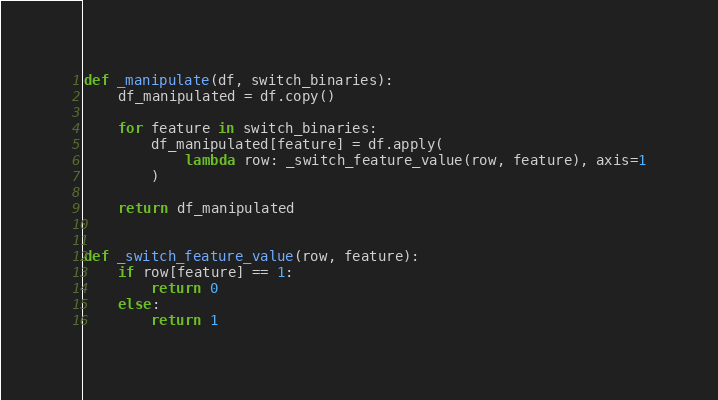Convert code to text. <code><loc_0><loc_0><loc_500><loc_500><_Python_>def _manipulate(df, switch_binaries):
    df_manipulated = df.copy()

    for feature in switch_binaries:
        df_manipulated[feature] = df.apply(
            lambda row: _switch_feature_value(row, feature), axis=1
        )

    return df_manipulated


def _switch_feature_value(row, feature):
    if row[feature] == 1:
        return 0
    else:
        return 1
</code> 